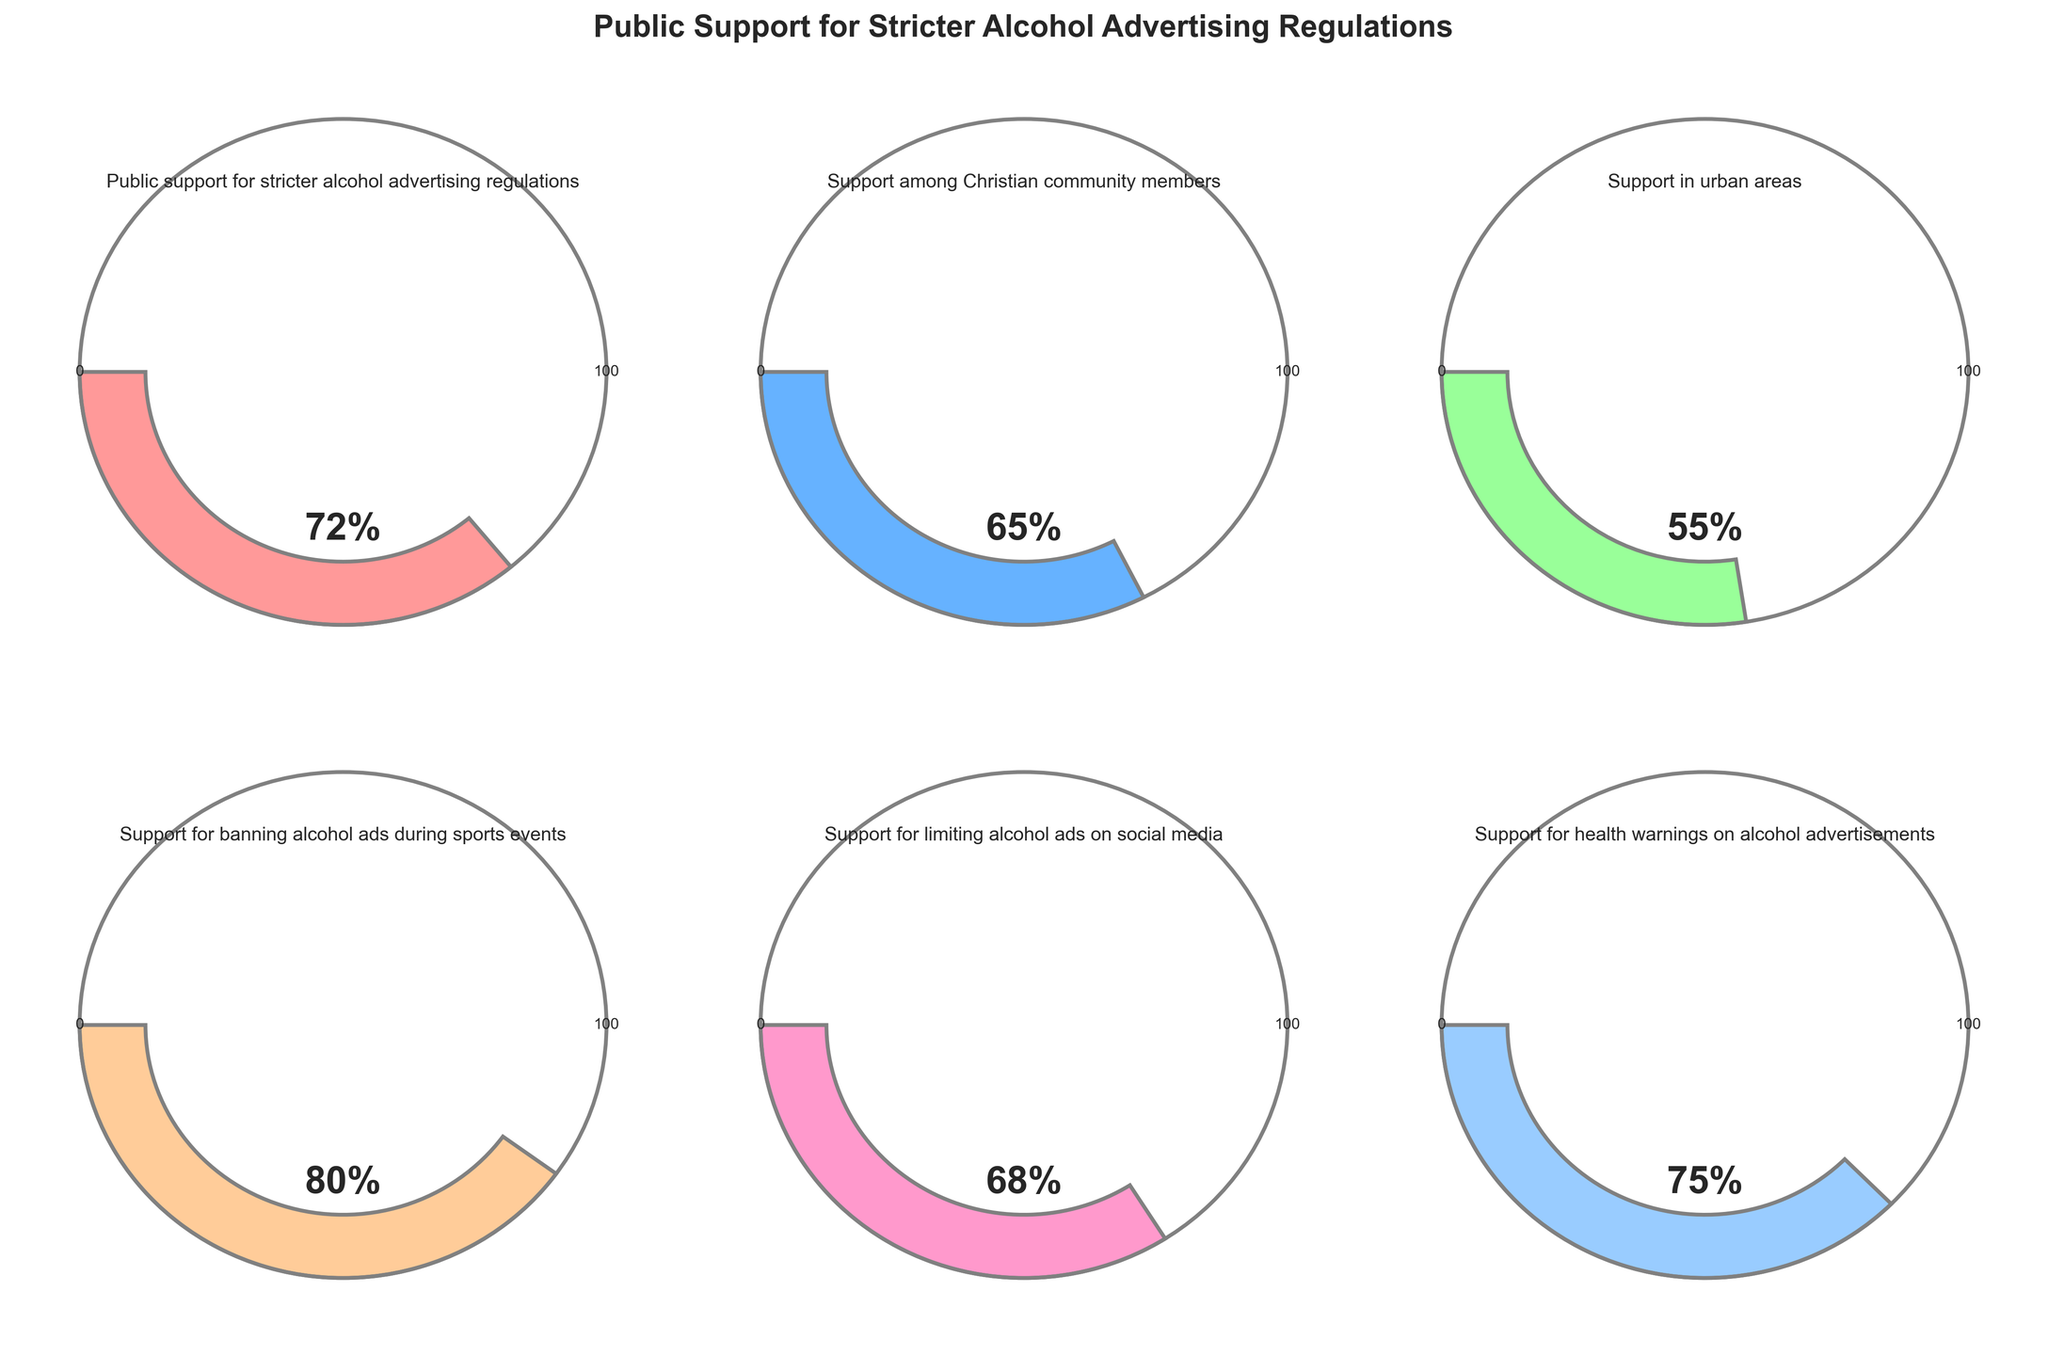What is the title of the figure? The title is displayed at the top of the figure, providing a summary of what the figure represents.
Answer: Public Support for Stricter Alcohol Advertising Regulations How many different gauges are displayed in the figure? The figure features a grid of 2 rows and 3 columns of gauges.
Answer: 6 What is the level of public support for banning alcohol ads during sports events? The gauge labeled "Support for banning alcohol ads during sports events" shows the value, which is the angle filled by the wedge.
Answer: 80% Which category shows the lowest level of support? By comparing the filled wedges in each gauge, the category with the smallest angle, and thus the lowest value, can be identified.
Answer: Support in urban areas Which category has the highest level of support? By comparing the filled wedges in each gauge, the category with the largest angle, and thus the highest value, can be identified.
Answer: Support for banning alcohol ads during sports events What is the average level of support across all categories? Add all the percentages and divide by the total number of categories: (72 + 65 + 55 + 80 + 68 + 75) / 6 = 69.17%.
Answer: 69.17% How much higher is the support for health warnings on alcohol advertisements compared to support in urban areas? Subtract the support in urban areas value from the support for health warnings on alcohol advertisements: 75% - 55% = 20%.
Answer: 20% Is the support among the Christian community members higher or lower than the public support? Compare the support among Christian community members (65%) to the public support (72%).
Answer: Lower What is the combined level of support for both restrictions on social media advertising and urban areas? Sum the values for support for limiting alcohol ads on social media and support in urban areas: 68% + 55% = 123%.
Answer: 123% Which category's support level is closest to the public support for stricter alcohol advertising regulations? Compare the value of public support (72%) with other categories and find the closest one. Support for health warnings on alcohol advertisements at 75% is the closest.
Answer: Support for health warnings on alcohol advertisements (75%) 